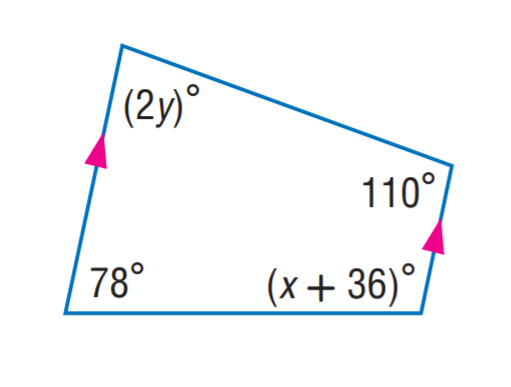Answer the mathemtical geometry problem and directly provide the correct option letter.
Question: Find y.
Choices: A: 35 B: 36 C: 66 D: 78 A 